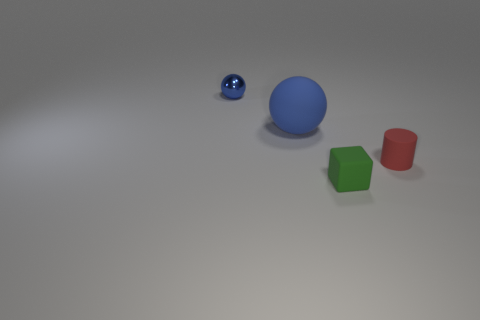Add 2 small blue shiny objects. How many objects exist? 6 Subtract all blocks. How many objects are left? 3 Subtract all big things. Subtract all red rubber cylinders. How many objects are left? 2 Add 2 big things. How many big things are left? 3 Add 3 gray cylinders. How many gray cylinders exist? 3 Subtract 0 yellow cylinders. How many objects are left? 4 